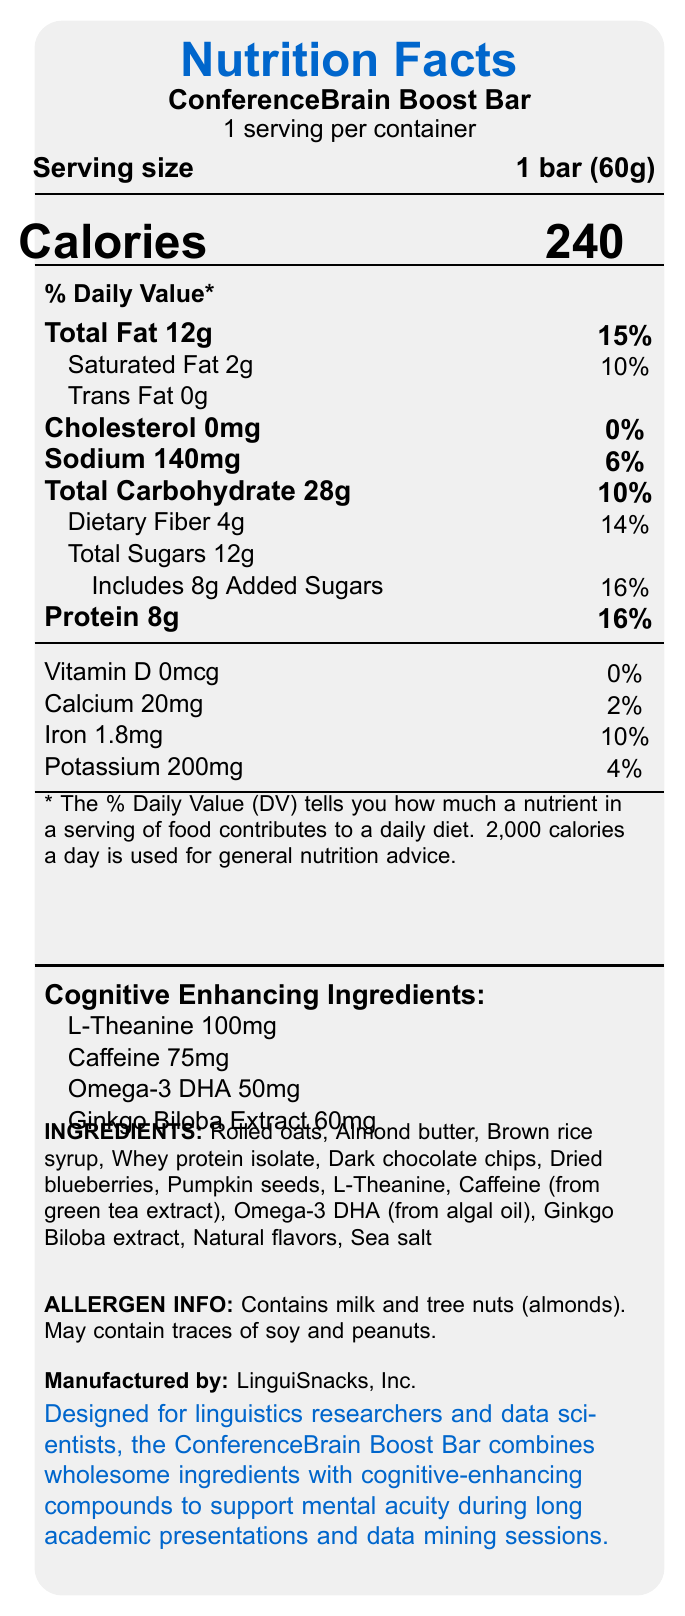What is the serving size of the ConferenceBrain Boost Bar? The serving size is listed as "1 bar (60g)" on the document near the top under the product name.
Answer: 1 bar (60g) How many calories does one ConferenceBrain Boost Bar contain? The number of calories is listed in a large font next to the word "Calories."
Answer: 240 What percentage of the Daily Value (DV) of dietary fiber does the ConferenceBrain Boost Bar provide? The DV percentage for dietary fiber is listed next to "Dietary Fiber 4g," which is shown as 14%.
Answer: 14% Which cognitive-enhancing ingredient has the highest amount in the ConferenceBrain Boost Bar? Among the cognitive-enhancing ingredients listed, L-Theanine has the highest amount at 100mg.
Answer: L-Theanine 100mg How many grams of protein are in one serving of the ConferenceBrain Boost Bar? The amount of protein per serving is listed as 8g on the document.
Answer: 8g What is the source of caffeine in the ConferenceBrain Boost Bar? A. Coffee beans B. Green tea extract C. Synthetic caffeine D. Black tea extract The source of caffeine is mentioned in the ingredients list as "Caffeine (from green tea extract)."
Answer: B. Green tea extract What is the total carbohydrate content of the ConferenceBrain Boost Bar? A. 28g B. 12g C. 16g D. 20g The total carbohydrate content is listed as "Total Carbohydrate 28g" on the document.
Answer: A. 28g Does the ConferenceBrain Boost Bar contain any cholesterol? The document lists "Cholesterol 0mg" with a 0% Daily Value.
Answer: No Summarize the main purpose of the ConferenceBrain Boost Bar. The document includes a product description at the bottom stating its purpose for supporting mental acuity during long academic activities by combining wholesome ingredients and cognitive enhancers.
Answer: The ConferenceBrain Boost Bar is designed for linguistics researchers and data scientists to support mental acuity during long academic presentations and data mining sessions, combining wholesome ingredients with cognitive-enhancing compounds. What is the amount of potassium in the ConferenceBrain Boost Bar? The potassium content is listed as "Potassium 200mg" on the document.
Answer: 200mg Is the ConferenceBrain Boost Bar suitable for people with tree nut allergies? The allergen information states that the product contains tree nuts (almonds).
Answer: No How much calcium does the ConferenceBrain Boost Bar provide as a percentage of the Daily Value? The document lists "Calcium 20mg" with a Daily Value of 2%.
Answer: 2% Identify all cognitive-enhancing ingredients in the ConferenceBrain Boost Bar. These ingredients are listed under "Cognitive Enhancing Ingredients."
Answer: L-Theanine 100mg, Caffeine 75mg, Omega-3 DHA 50mg, Ginkgo Biloba Extract 60mg Which ingredient is not listed among the cognitive-enhancing ingredients in the ConferenceBrain Boost Bar? A. L-Theanine B. Caffeine C. Omega-3 DHA D. Citicoline Citicoline is not listed among the cognitive-enhancing ingredients in the document.
Answer: D. Citicoline For a person on a 2,000 calorie diet, what percentage of their daily intake is fulfilled by consuming one ConferenceBrain Boost Bar? One bar contains 240 calories, which is 12% of a 2,000 calorie diet (calculated as (240/2000) * 100).
Answer: 12% Are there any ingredients in the ConferenceBrain Boost Bar that may be beneficial for cognitive function? The document lists cognitive-enhancing ingredients such as L-Theanine, Caffeine, Omega-3 DHA, and Ginkgo Biloba Extract.
Answer: Yes What is the total amount of added sugars in the ConferenceBrain Boost Bar? The document lists "Includes 8g Added Sugars."
Answer: 8g How much iron does the ConferenceBrain Boost Bar provide? The iron content is listed as "Iron 1.8mg" on the document.
Answer: 1.8mg What are the main components of the nutrition facts for the ConferenceBrain Boost Bar? The main components are listed throughout the document, including the breakdown of fats, carbohydrates, proteins, vitamins, minerals, and cognitive-enhancing ingredients.
Answer: Serving size, Calories, Total Fat, Saturated Fat, Trans Fat, Cholesterol, Sodium, Total Carbohydrate, Dietary Fiber, Total Sugars, Added Sugars, Protein, Vitamin D, Calcium, Iron, Potassium, and Cognitive Enhancing Ingredients. How much Omega-3 DHA is in the ConferenceBrain Boost Bar? The amount of Omega-3 DHA is listed in the cognitive-enhancing ingredients section as 50mg.
Answer: 50mg Does the ConferenceBrain Boost Bar contain any vitamin D? The document lists "Vitamin D 0mcg" with a 0% Daily Value.
Answer: No How many ingredients does the ConferenceBrain Boost Bar contain? The document lists 13 ingredients in the "INGREDIENTS" section.
Answer: 13 What is the name of the manufacturer of the ConferenceBrain Boost Bar? The manufacturer is listed near the bottom of the document.
Answer: LinguiSnacks, Inc. What is the price of the ConferenceBrain Boost Bar? The document does not provide any information on the price of the product.
Answer: Cannot be determined 